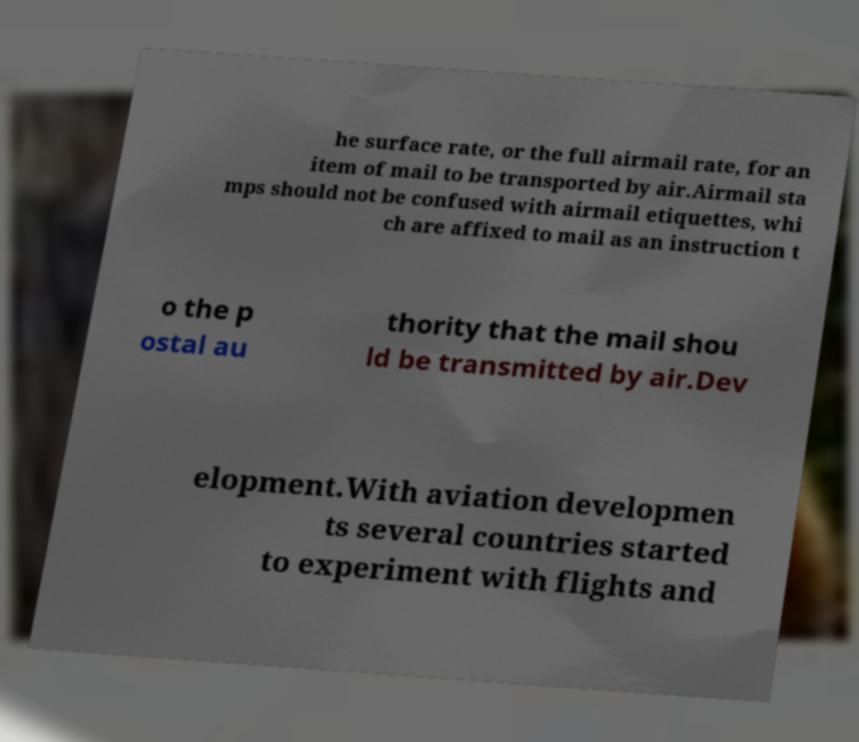For documentation purposes, I need the text within this image transcribed. Could you provide that? he surface rate, or the full airmail rate, for an item of mail to be transported by air.Airmail sta mps should not be confused with airmail etiquettes, whi ch are affixed to mail as an instruction t o the p ostal au thority that the mail shou ld be transmitted by air.Dev elopment.With aviation developmen ts several countries started to experiment with flights and 